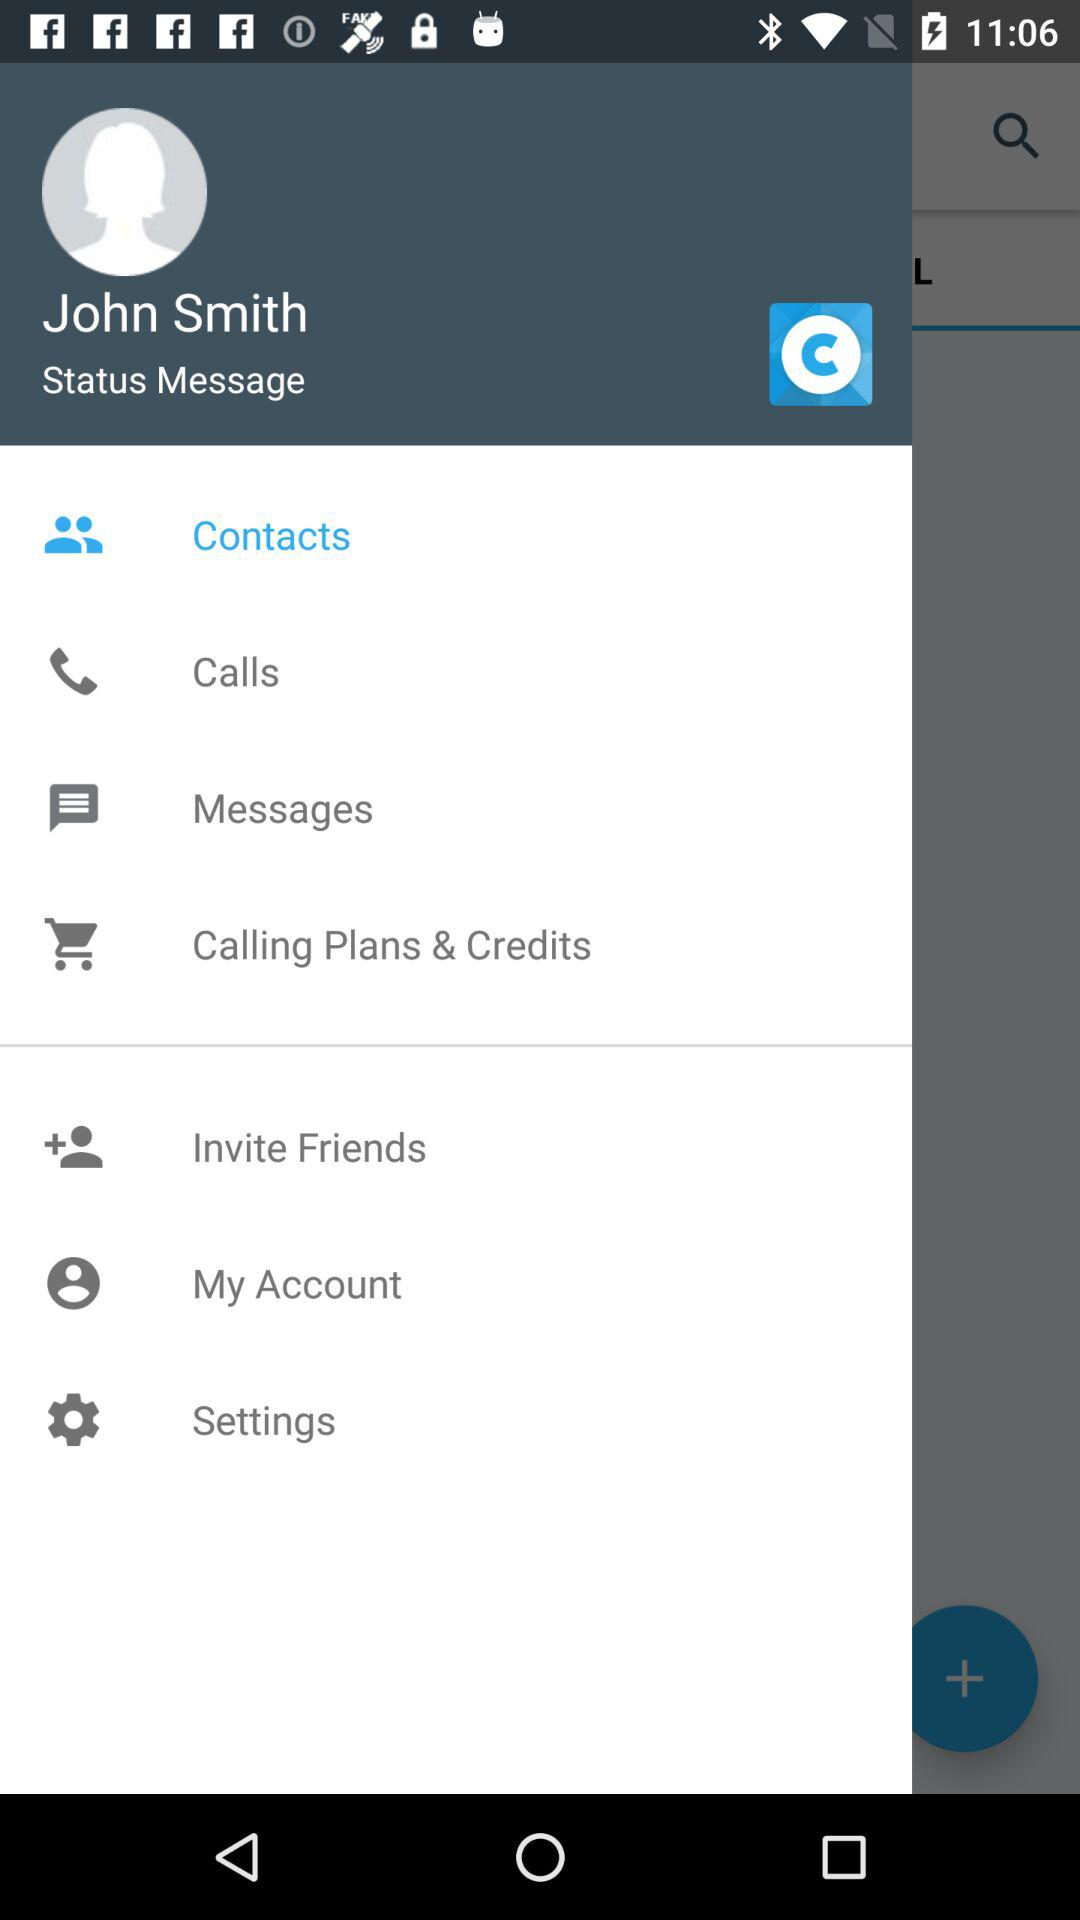Which item is selected? The selected item is "Contacts". 